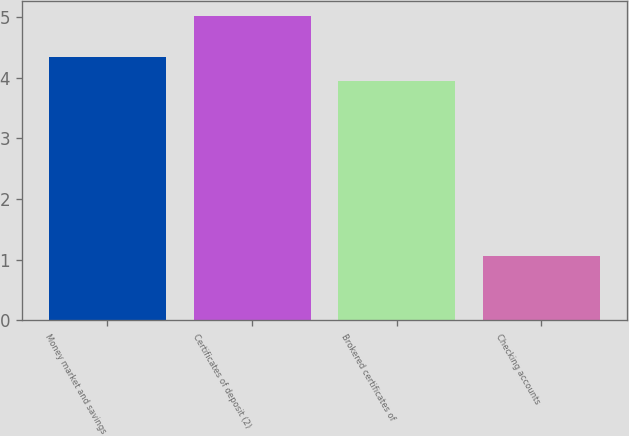Convert chart. <chart><loc_0><loc_0><loc_500><loc_500><bar_chart><fcel>Money market and savings<fcel>Certificates of deposit (2)<fcel>Brokered certificates of<fcel>Checking accounts<nl><fcel>4.35<fcel>5.02<fcel>3.95<fcel>1.06<nl></chart> 